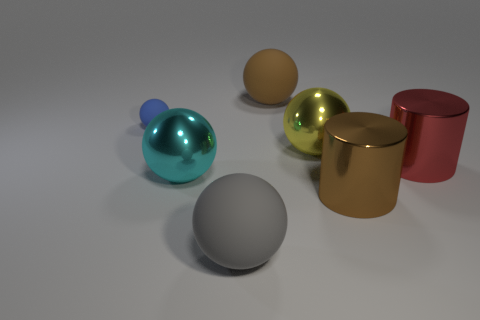Is there any other thing that has the same size as the blue sphere?
Your answer should be very brief. No. There is a metallic thing that is left of the yellow metal ball; what size is it?
Your answer should be very brief. Large. What is the color of the other large thing that is the same shape as the large red shiny object?
Provide a short and direct response. Brown. Are there any large balls left of the big metallic object that is left of the metal ball right of the gray sphere?
Ensure brevity in your answer.  No. How many large cylinders have the same material as the gray ball?
Keep it short and to the point. 0. Does the shiny thing on the left side of the brown rubber thing have the same size as the rubber ball that is to the left of the gray ball?
Provide a succinct answer. No. There is a big rubber thing that is behind the metallic cylinder that is to the right of the big metallic thing that is in front of the cyan ball; what color is it?
Your answer should be very brief. Brown. Is there a big brown rubber object of the same shape as the gray object?
Make the answer very short. Yes. Are there the same number of rubber objects that are in front of the large gray matte thing and large metal things that are in front of the yellow thing?
Make the answer very short. No. There is a big brown thing behind the large yellow shiny object; is it the same shape as the large red thing?
Your answer should be very brief. No. 